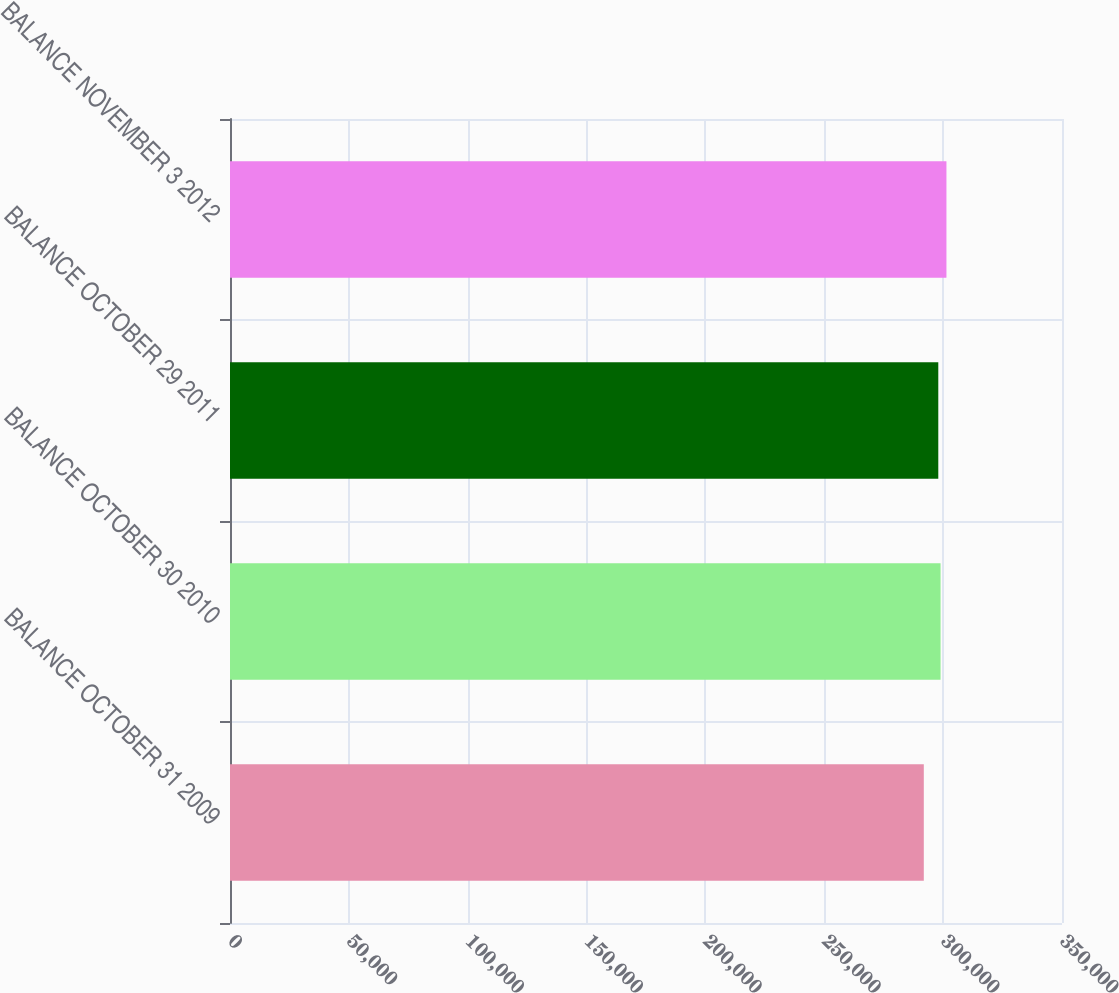Convert chart to OTSL. <chart><loc_0><loc_0><loc_500><loc_500><bar_chart><fcel>BALANCE OCTOBER 31 2009<fcel>BALANCE OCTOBER 30 2010<fcel>BALANCE OCTOBER 29 2011<fcel>BALANCE NOVEMBER 3 2012<nl><fcel>291862<fcel>298914<fcel>297961<fcel>301389<nl></chart> 